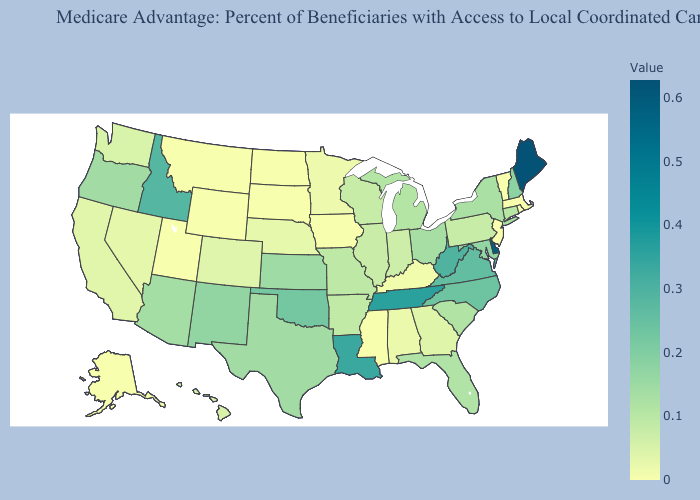Among the states that border Montana , does Idaho have the lowest value?
Concise answer only. No. Which states have the highest value in the USA?
Keep it brief. Maine. Does Missouri have the lowest value in the MidWest?
Answer briefly. No. Does the map have missing data?
Short answer required. No. 